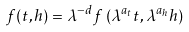<formula> <loc_0><loc_0><loc_500><loc_500>f ( t , h ) = \lambda ^ { - d } f \left ( \lambda ^ { a _ { t } } t , \lambda ^ { a _ { h } } h \right )</formula> 